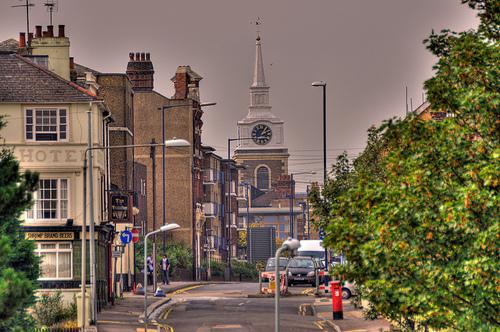Question: where was this photo taken?
Choices:
A. Countryside.
B. Village.
C. In a city.
D. Town.
Answer with the letter. Answer: C Question: what color is the sky?
Choices:
A. Blue.
B. White.
C. Gray.
D. Black.
Answer with the letter. Answer: C Question: who is the subject of the photo?
Choices:
A. The building.
B. The street.
C. The tree.
D. The restaurant.
Answer with the letter. Answer: B Question: what color are the leaves?
Choices:
A. Orange.
B. Green.
C. Red.
D. Yellow.
Answer with the letter. Answer: B 